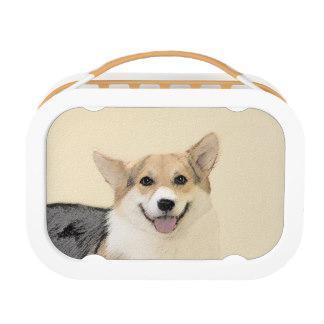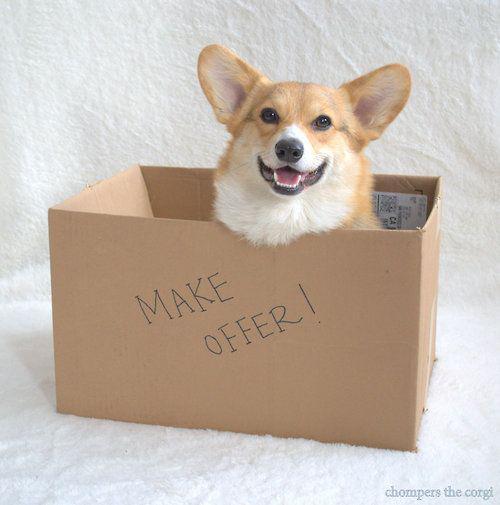The first image is the image on the left, the second image is the image on the right. Evaluate the accuracy of this statement regarding the images: "A dog is in a brown cardboard box with its flaps folding outward instead of tucked inward.". Is it true? Answer yes or no. No. 